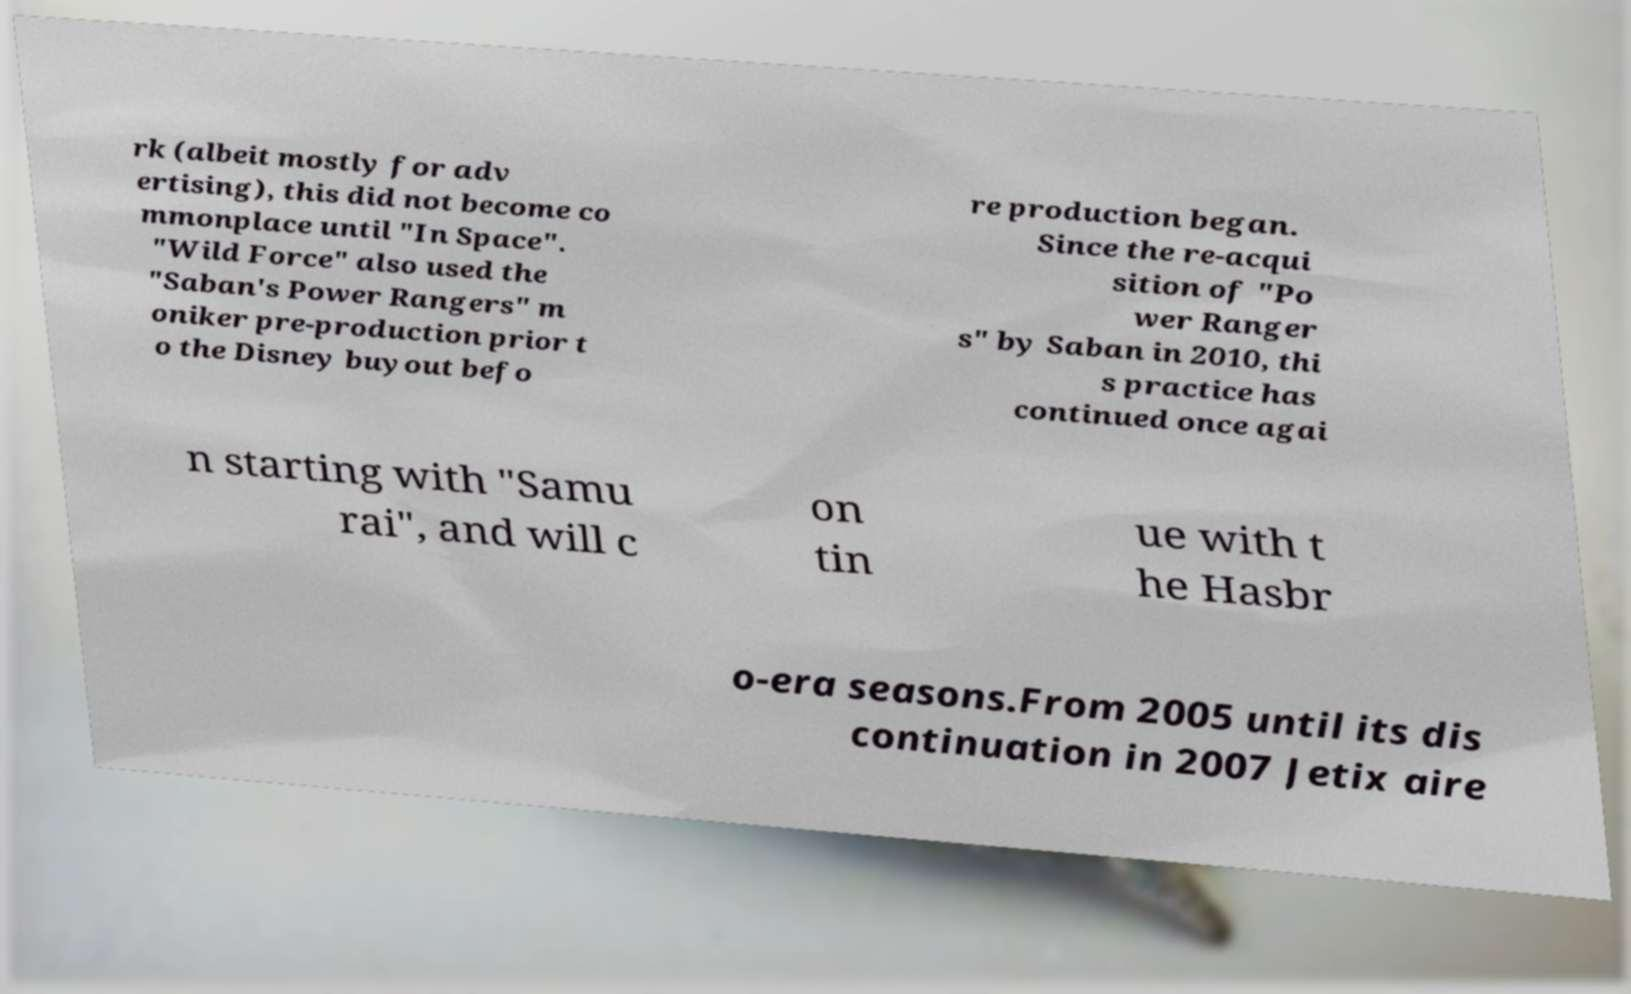Can you accurately transcribe the text from the provided image for me? rk (albeit mostly for adv ertising), this did not become co mmonplace until "In Space". "Wild Force" also used the "Saban's Power Rangers" m oniker pre-production prior t o the Disney buyout befo re production began. Since the re-acqui sition of "Po wer Ranger s" by Saban in 2010, thi s practice has continued once agai n starting with "Samu rai", and will c on tin ue with t he Hasbr o-era seasons.From 2005 until its dis continuation in 2007 Jetix aire 